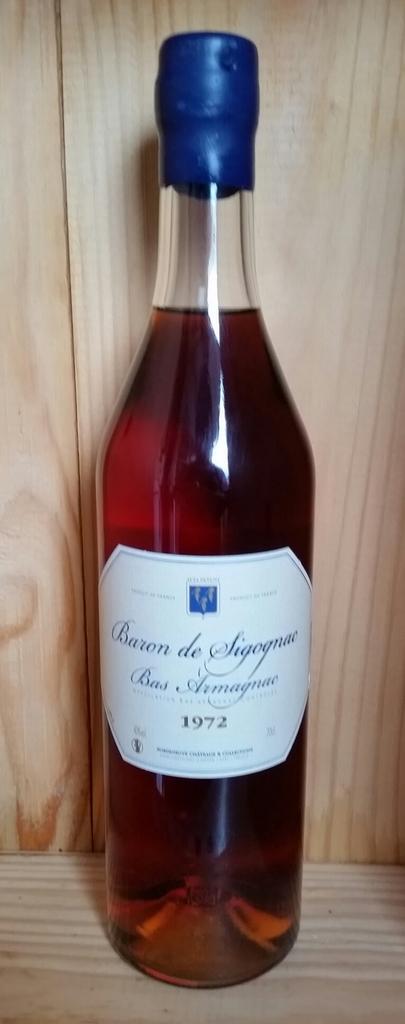What year was this wine made?
Your answer should be compact. 1972. What colour is the wine bottle top?
Provide a short and direct response. Blue. 